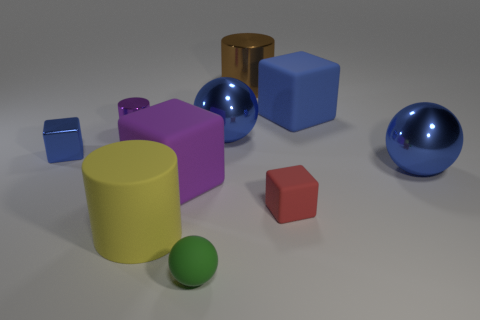Subtract all cyan cubes. Subtract all brown cylinders. How many cubes are left? 4 Subtract all cylinders. How many objects are left? 7 Subtract all matte things. Subtract all blue metallic things. How many objects are left? 2 Add 8 big yellow matte cylinders. How many big yellow matte cylinders are left? 9 Add 1 big cubes. How many big cubes exist? 3 Subtract 1 purple blocks. How many objects are left? 9 